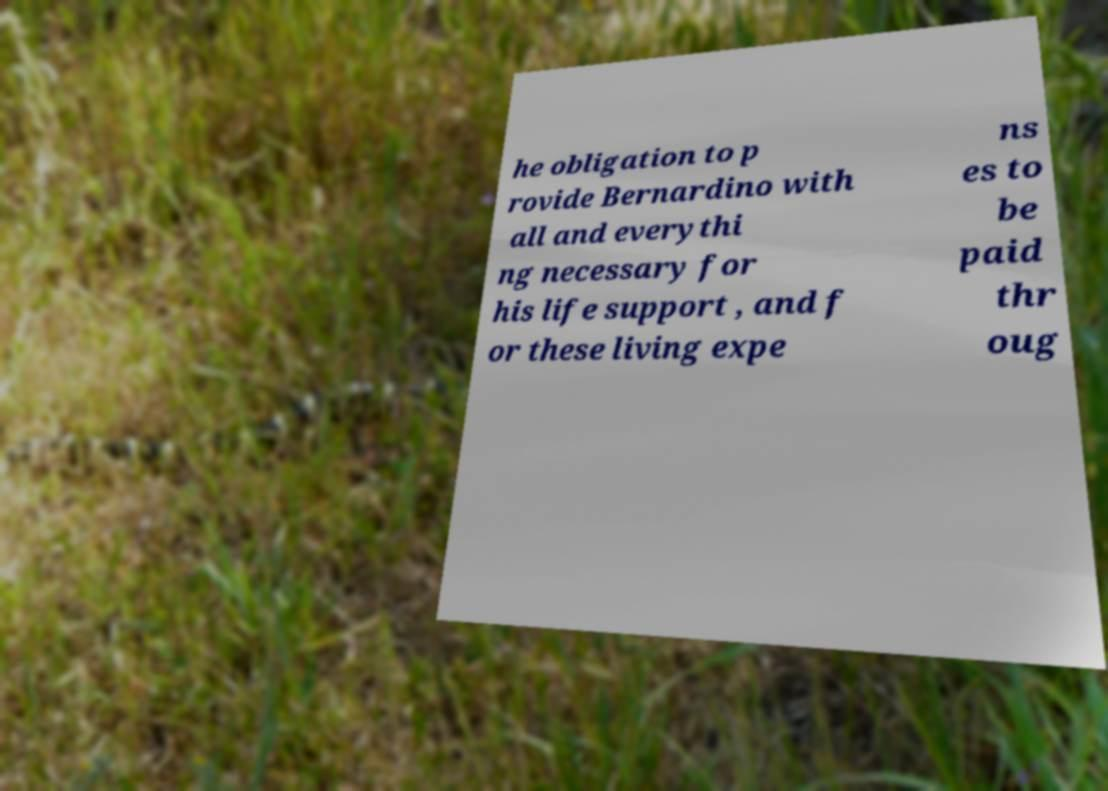There's text embedded in this image that I need extracted. Can you transcribe it verbatim? he obligation to p rovide Bernardino with all and everythi ng necessary for his life support , and f or these living expe ns es to be paid thr oug 